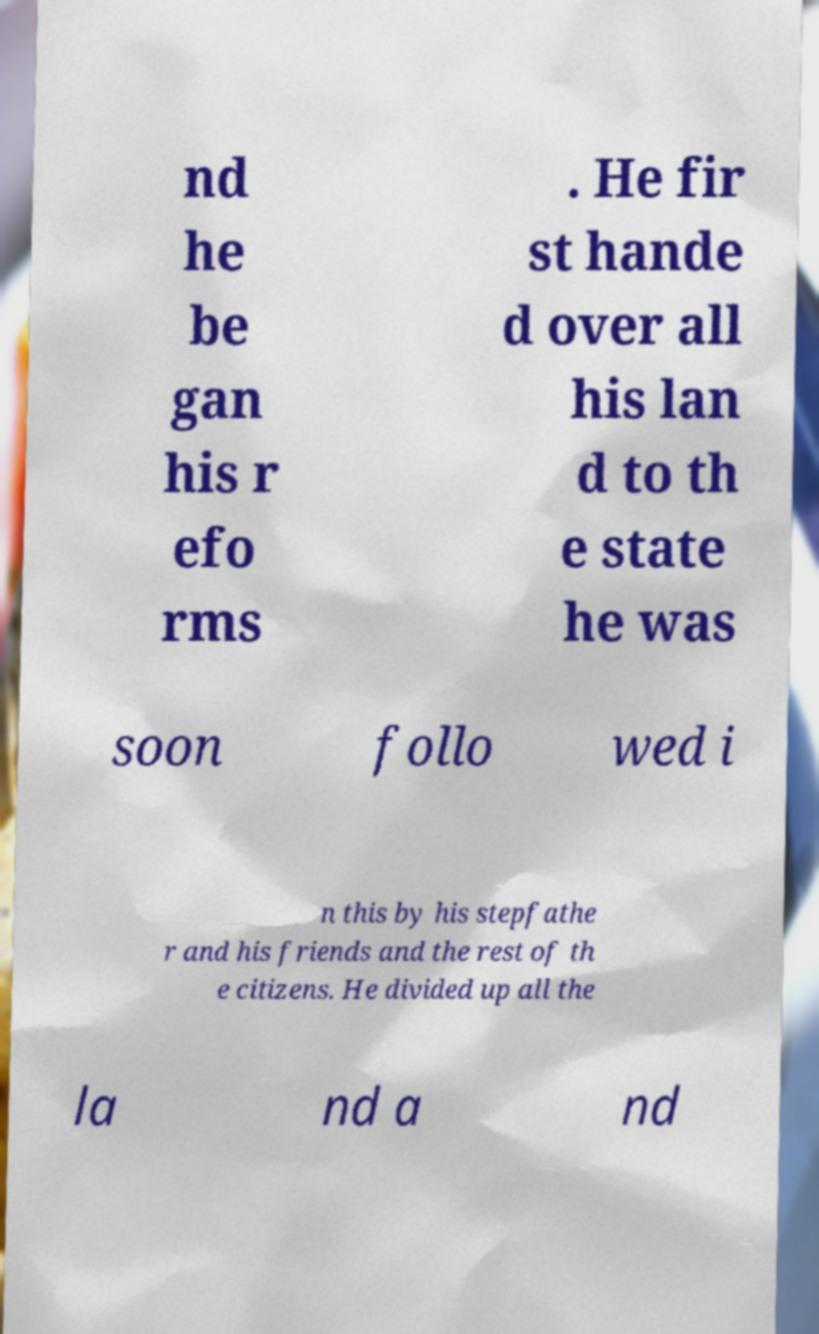Could you assist in decoding the text presented in this image and type it out clearly? nd he be gan his r efo rms . He fir st hande d over all his lan d to th e state he was soon follo wed i n this by his stepfathe r and his friends and the rest of th e citizens. He divided up all the la nd a nd 